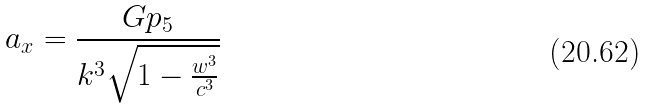Convert formula to latex. <formula><loc_0><loc_0><loc_500><loc_500>a _ { x } = \frac { G p _ { 5 } } { k ^ { 3 } \sqrt { 1 - \frac { w ^ { 3 } } { c ^ { 3 } } } }</formula> 